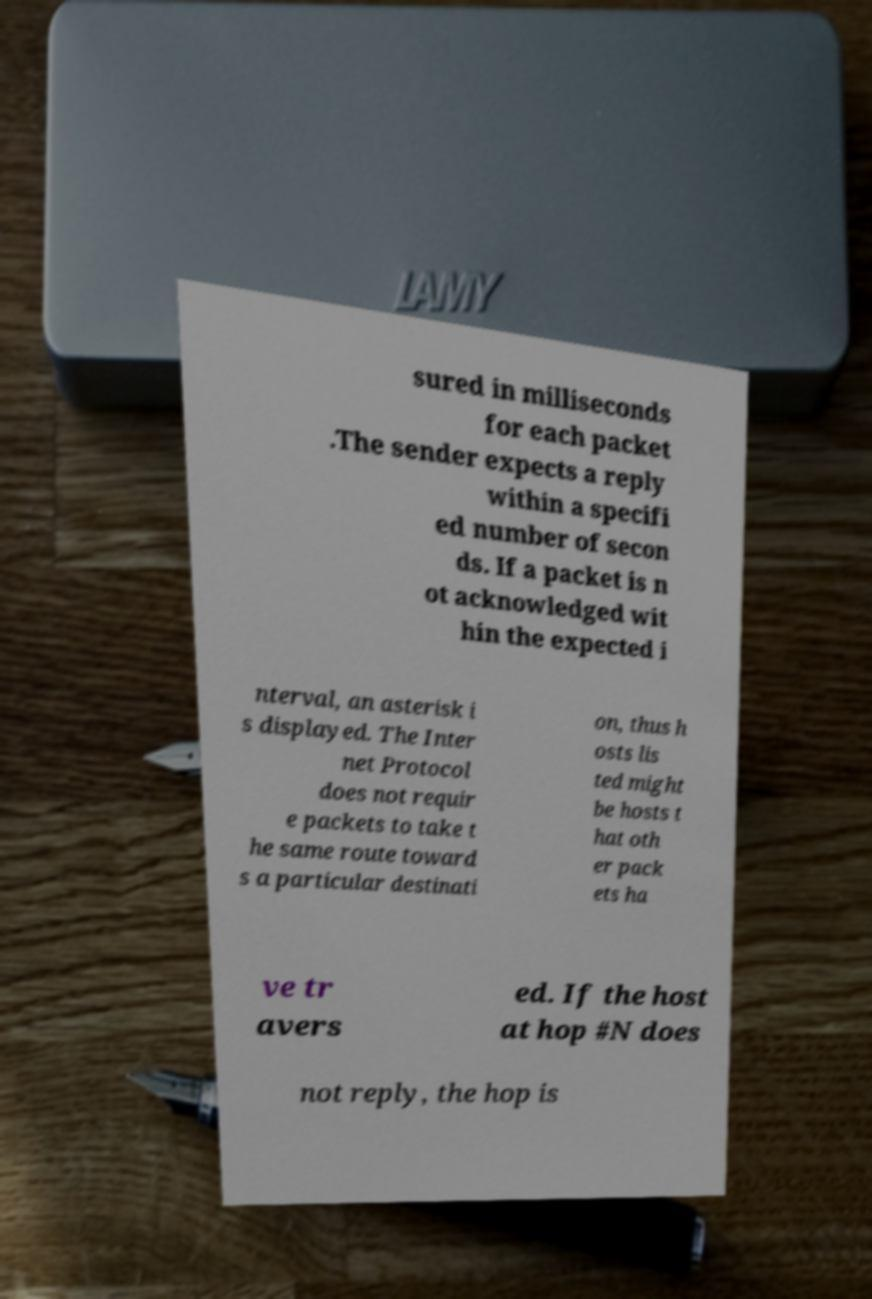What messages or text are displayed in this image? I need them in a readable, typed format. sured in milliseconds for each packet .The sender expects a reply within a specifi ed number of secon ds. If a packet is n ot acknowledged wit hin the expected i nterval, an asterisk i s displayed. The Inter net Protocol does not requir e packets to take t he same route toward s a particular destinati on, thus h osts lis ted might be hosts t hat oth er pack ets ha ve tr avers ed. If the host at hop #N does not reply, the hop is 